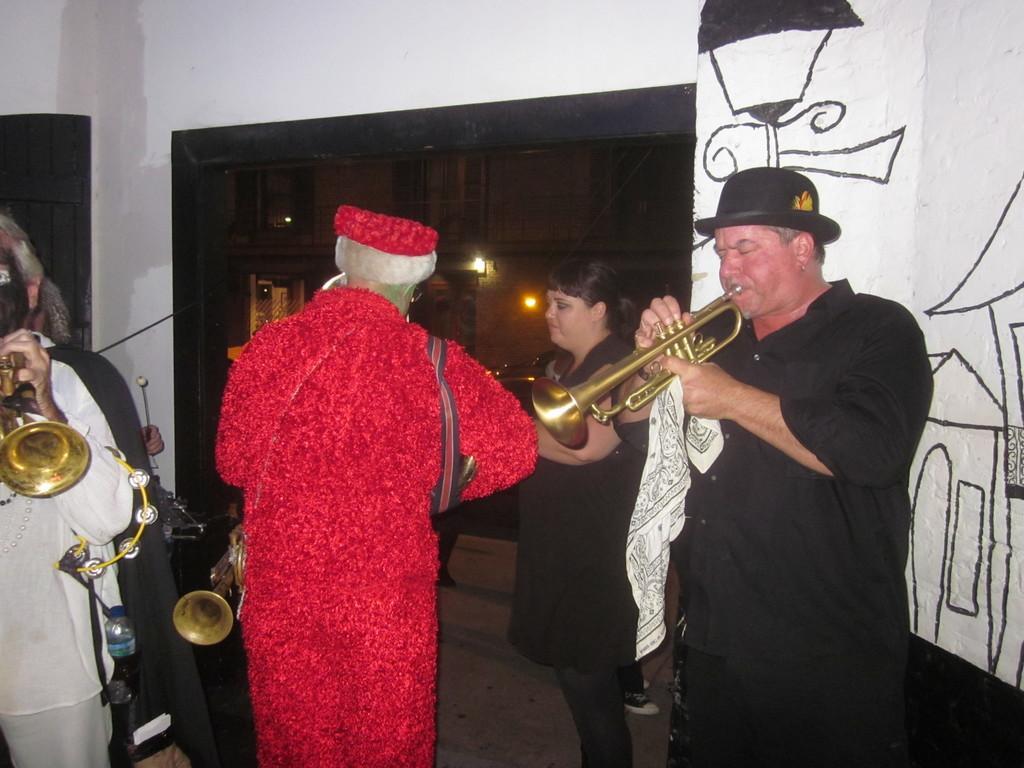Describe this image in one or two sentences. In this image we can see a group of people standing on the floor holding some musical instruments. In that we can see a man holding a cloth. On the backside we can see some lights, cupboards, a door and some painting on a wall. 